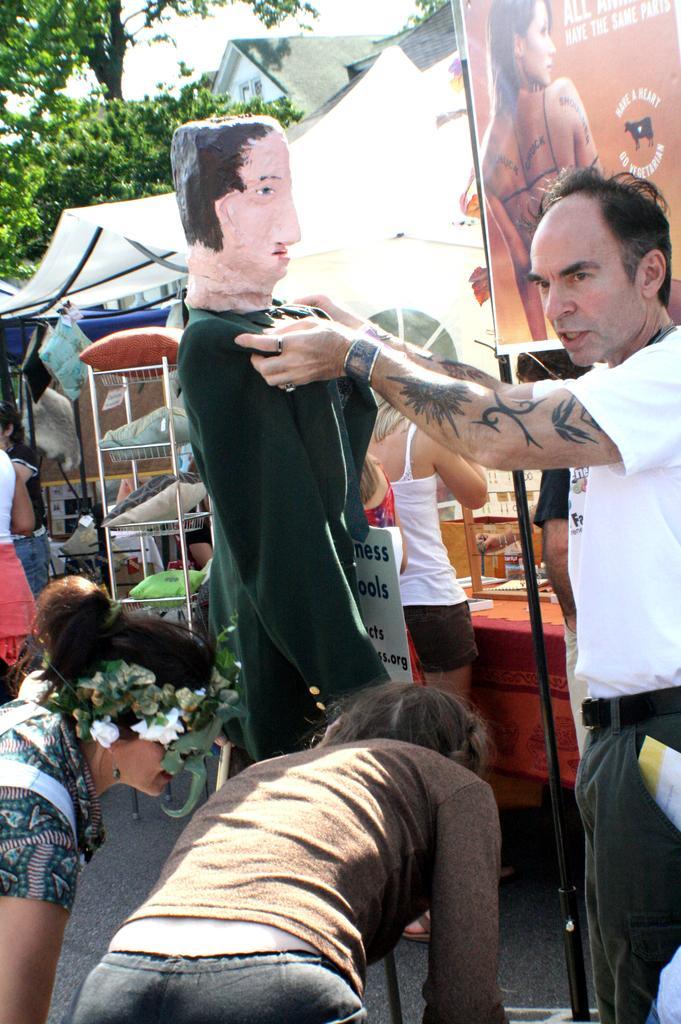Could you give a brief overview of what you see in this image? In this image we can see the people standing on the ground. And we can see the stalls and the statue. In the background, we can see the trees, building and sky and we can see the banner with text and image. 